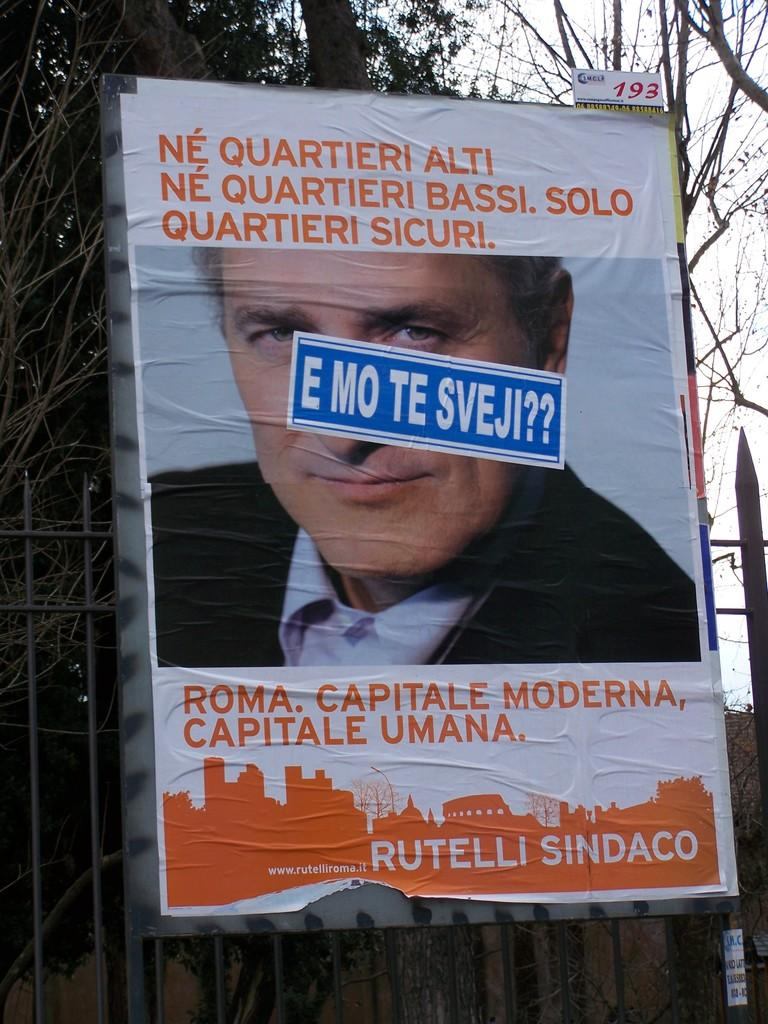What is depicted on the poster in the image? There is a poster of a man in the image. What can be seen in the background of the image? There are trees visible in the background of the image. What type of holiday is being celebrated in the image? There is no indication of a holiday being celebrated in the image. What tax-related information can be found on the poster? There is no tax-related information present on the poster, as it features a man. Can you see the seashore in the background of the image? No, the background of the image features trees, not the seashore. 